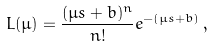<formula> <loc_0><loc_0><loc_500><loc_500>L ( \mu ) = \frac { ( \mu s + b ) ^ { n } } { n ! } e ^ { - ( \mu s + b ) } \, ,</formula> 